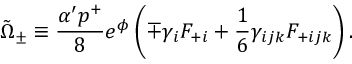Convert formula to latex. <formula><loc_0><loc_0><loc_500><loc_500>\tilde { \Omega } _ { \pm } \equiv \frac { \alpha ^ { \prime } p ^ { + } } { 8 } e ^ { \phi } \left ( \mp \gamma _ { i } F _ { + i } + { \frac { 1 } { 6 } } \gamma _ { i j k } F _ { + i j k } \right ) .</formula> 